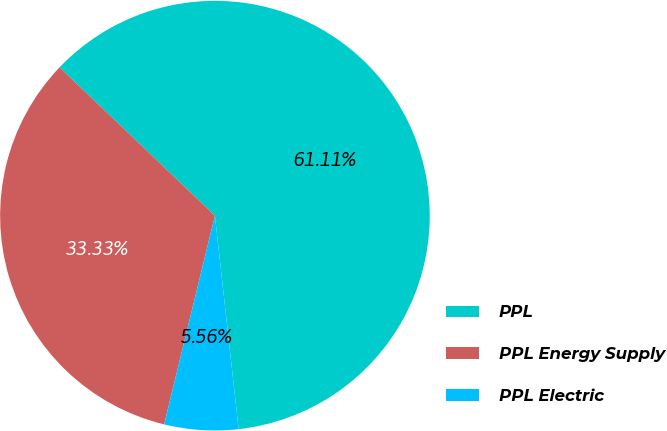Convert chart to OTSL. <chart><loc_0><loc_0><loc_500><loc_500><pie_chart><fcel>PPL<fcel>PPL Energy Supply<fcel>PPL Electric<nl><fcel>61.11%<fcel>33.33%<fcel>5.56%<nl></chart> 